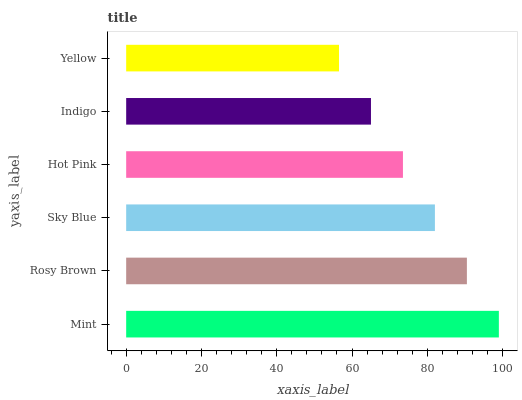Is Yellow the minimum?
Answer yes or no. Yes. Is Mint the maximum?
Answer yes or no. Yes. Is Rosy Brown the minimum?
Answer yes or no. No. Is Rosy Brown the maximum?
Answer yes or no. No. Is Mint greater than Rosy Brown?
Answer yes or no. Yes. Is Rosy Brown less than Mint?
Answer yes or no. Yes. Is Rosy Brown greater than Mint?
Answer yes or no. No. Is Mint less than Rosy Brown?
Answer yes or no. No. Is Sky Blue the high median?
Answer yes or no. Yes. Is Hot Pink the low median?
Answer yes or no. Yes. Is Rosy Brown the high median?
Answer yes or no. No. Is Mint the low median?
Answer yes or no. No. 